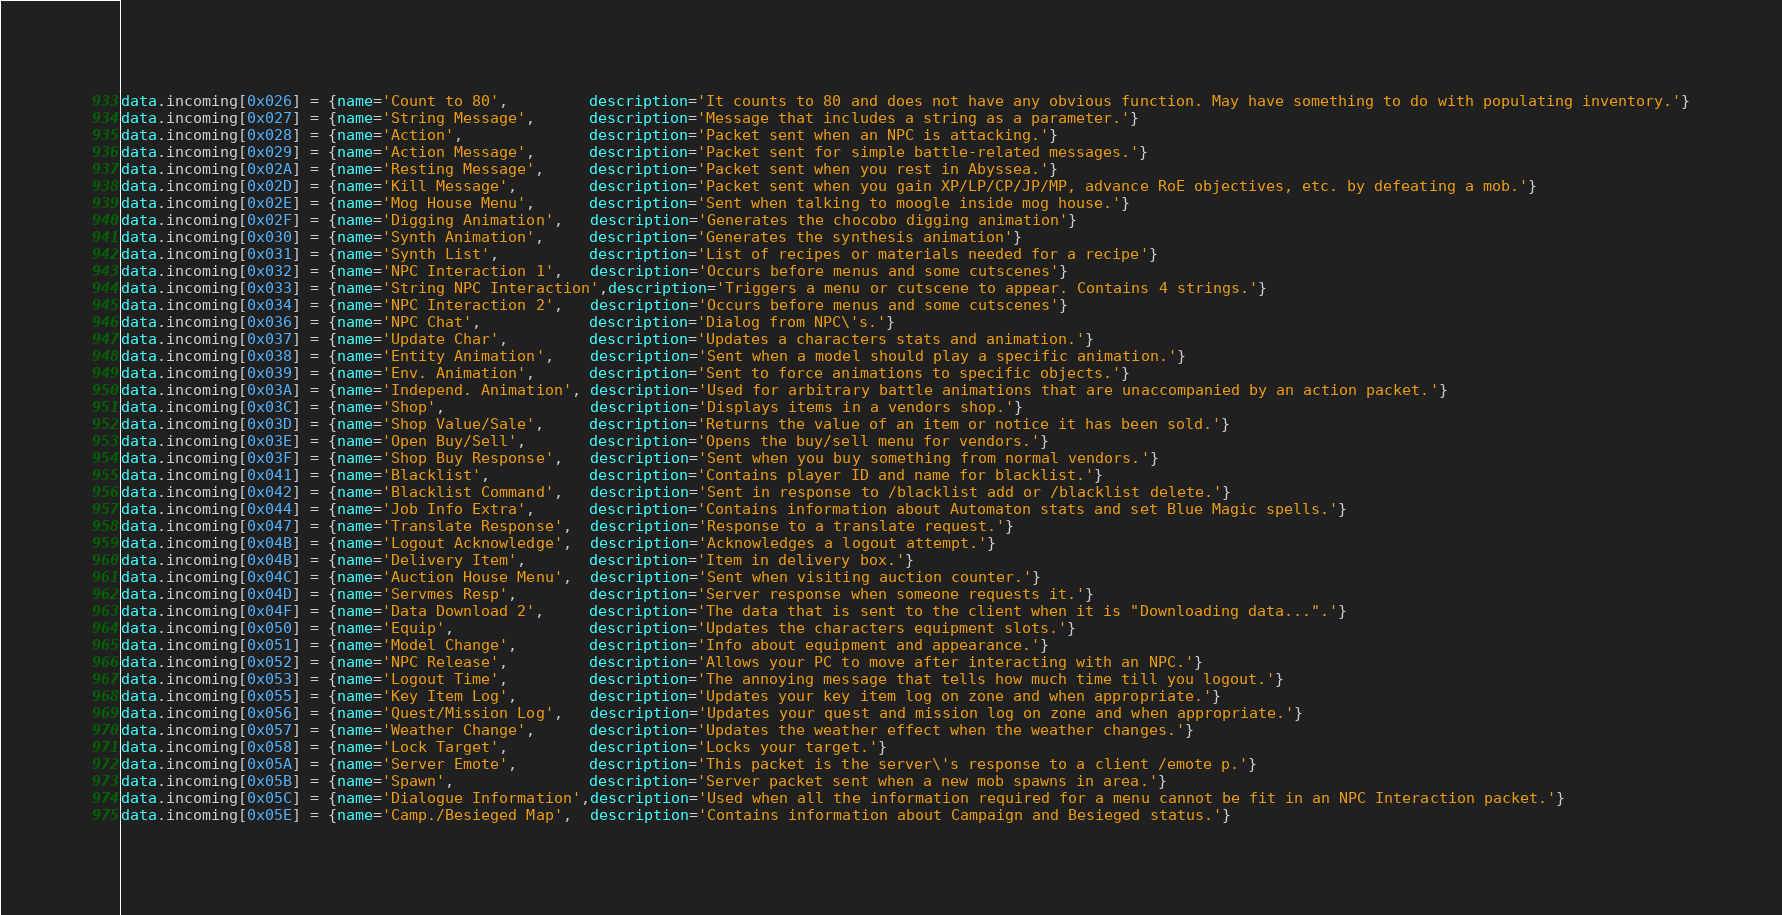<code> <loc_0><loc_0><loc_500><loc_500><_Lua_>data.incoming[0x026] = {name='Count to 80',         description='It counts to 80 and does not have any obvious function. May have something to do with populating inventory.'}
data.incoming[0x027] = {name='String Message',      description='Message that includes a string as a parameter.'}
data.incoming[0x028] = {name='Action',              description='Packet sent when an NPC is attacking.'}
data.incoming[0x029] = {name='Action Message',      description='Packet sent for simple battle-related messages.'}
data.incoming[0x02A] = {name='Resting Message',     description='Packet sent when you rest in Abyssea.'}
data.incoming[0x02D] = {name='Kill Message',        description='Packet sent when you gain XP/LP/CP/JP/MP, advance RoE objectives, etc. by defeating a mob.'}
data.incoming[0x02E] = {name='Mog House Menu',      description='Sent when talking to moogle inside mog house.'}
data.incoming[0x02F] = {name='Digging Animation',   description='Generates the chocobo digging animation'}
data.incoming[0x030] = {name='Synth Animation',     description='Generates the synthesis animation'}
data.incoming[0x031] = {name='Synth List',          description='List of recipes or materials needed for a recipe'}
data.incoming[0x032] = {name='NPC Interaction 1',   description='Occurs before menus and some cutscenes'}
data.incoming[0x033] = {name='String NPC Interaction',description='Triggers a menu or cutscene to appear. Contains 4 strings.'}
data.incoming[0x034] = {name='NPC Interaction 2',   description='Occurs before menus and some cutscenes'}
data.incoming[0x036] = {name='NPC Chat',            description='Dialog from NPC\'s.'}
data.incoming[0x037] = {name='Update Char',         description='Updates a characters stats and animation.'}
data.incoming[0x038] = {name='Entity Animation',    description='Sent when a model should play a specific animation.'}
data.incoming[0x039] = {name='Env. Animation',      description='Sent to force animations to specific objects.'}
data.incoming[0x03A] = {name='Independ. Animation', description='Used for arbitrary battle animations that are unaccompanied by an action packet.'}
data.incoming[0x03C] = {name='Shop',                description='Displays items in a vendors shop.'}
data.incoming[0x03D] = {name='Shop Value/Sale',     description='Returns the value of an item or notice it has been sold.'}
data.incoming[0x03E] = {name='Open Buy/Sell',       description='Opens the buy/sell menu for vendors.'}
data.incoming[0x03F] = {name='Shop Buy Response',   description='Sent when you buy something from normal vendors.'}
data.incoming[0x041] = {name='Blacklist',           description='Contains player ID and name for blacklist.'}
data.incoming[0x042] = {name='Blacklist Command',   description='Sent in response to /blacklist add or /blacklist delete.'}
data.incoming[0x044] = {name='Job Info Extra',      description='Contains information about Automaton stats and set Blue Magic spells.'}
data.incoming[0x047] = {name='Translate Response',  description='Response to a translate request.'}
data.incoming[0x04B] = {name='Logout Acknowledge',  description='Acknowledges a logout attempt.'}
data.incoming[0x04B] = {name='Delivery Item',       description='Item in delivery box.'}
data.incoming[0x04C] = {name='Auction House Menu',  description='Sent when visiting auction counter.'}
data.incoming[0x04D] = {name='Servmes Resp',        description='Server response when someone requests it.'}
data.incoming[0x04F] = {name='Data Download 2',     description='The data that is sent to the client when it is "Downloading data...".'}
data.incoming[0x050] = {name='Equip',               description='Updates the characters equipment slots.'}
data.incoming[0x051] = {name='Model Change',        description='Info about equipment and appearance.'}
data.incoming[0x052] = {name='NPC Release',         description='Allows your PC to move after interacting with an NPC.'}
data.incoming[0x053] = {name='Logout Time',         description='The annoying message that tells how much time till you logout.'}
data.incoming[0x055] = {name='Key Item Log',        description='Updates your key item log on zone and when appropriate.'}
data.incoming[0x056] = {name='Quest/Mission Log',   description='Updates your quest and mission log on zone and when appropriate.'}
data.incoming[0x057] = {name='Weather Change',      description='Updates the weather effect when the weather changes.'}
data.incoming[0x058] = {name='Lock Target',         description='Locks your target.'}
data.incoming[0x05A] = {name='Server Emote',        description='This packet is the server\'s response to a client /emote p.'}
data.incoming[0x05B] = {name='Spawn',               description='Server packet sent when a new mob spawns in area.'}
data.incoming[0x05C] = {name='Dialogue Information',description='Used when all the information required for a menu cannot be fit in an NPC Interaction packet.'}
data.incoming[0x05E] = {name='Camp./Besieged Map',  description='Contains information about Campaign and Besieged status.'}</code> 